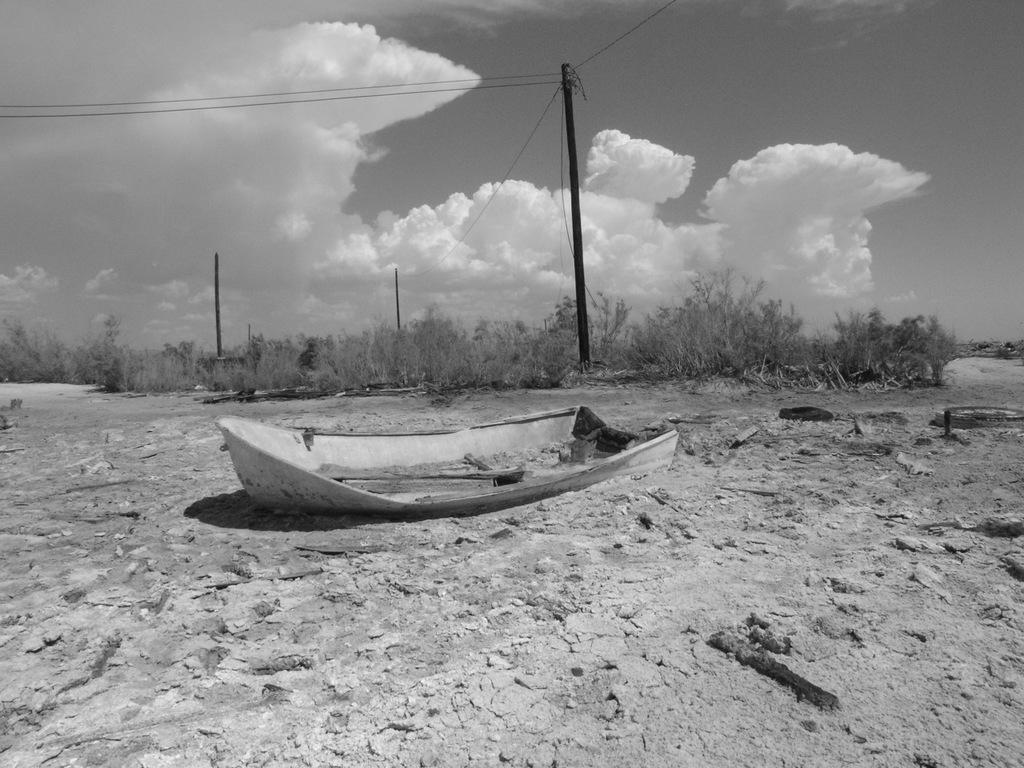What is the main subject of the image? There is a boat in the image. What type of vegetation can be seen in the image? There are bushes in the image. What structures are present in the image? There are poles and wires in the image. What can be seen in the sky in the image? There are clouds in the image. What is visible in the background of the image? The sky is visible in the image. What is the color scheme of the image? The image is black and white in color. What type of blood is visible on the boat in the image? There is no blood visible on the boat in the image; it is a black and white image, and blood would not be visible in such a color scheme. 